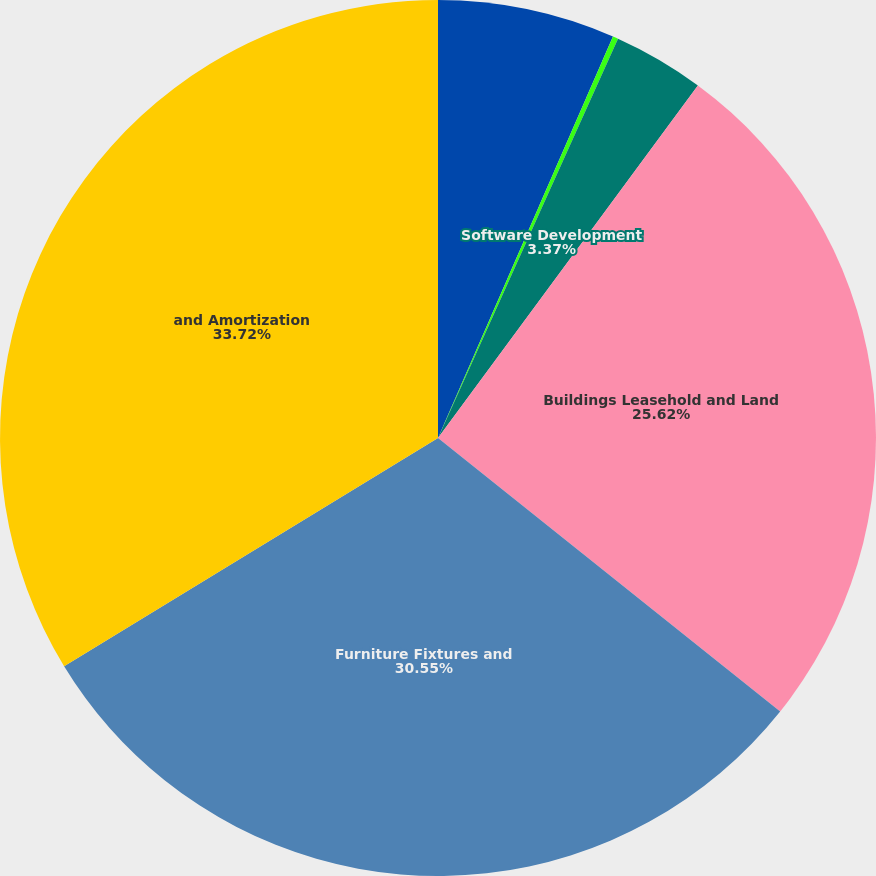Convert chart to OTSL. <chart><loc_0><loc_0><loc_500><loc_500><pie_chart><fcel>Land<fcel>Construction in Process<fcel>Software Development<fcel>Buildings Leasehold and Land<fcel>Furniture Fixtures and<fcel>and Amortization<nl><fcel>6.54%<fcel>0.2%<fcel>3.37%<fcel>25.62%<fcel>30.55%<fcel>33.72%<nl></chart> 